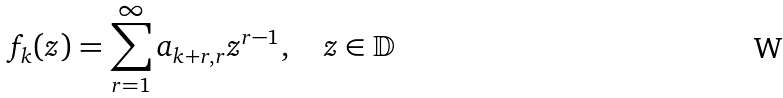<formula> <loc_0><loc_0><loc_500><loc_500>f _ { k } ( z ) = \sum _ { r = 1 } ^ { \infty } a _ { k + r , r } z ^ { r - 1 } , \quad z \in \mathbb { D }</formula> 